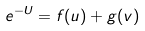Convert formula to latex. <formula><loc_0><loc_0><loc_500><loc_500>e ^ { - U } = f ( u ) + g ( v )</formula> 